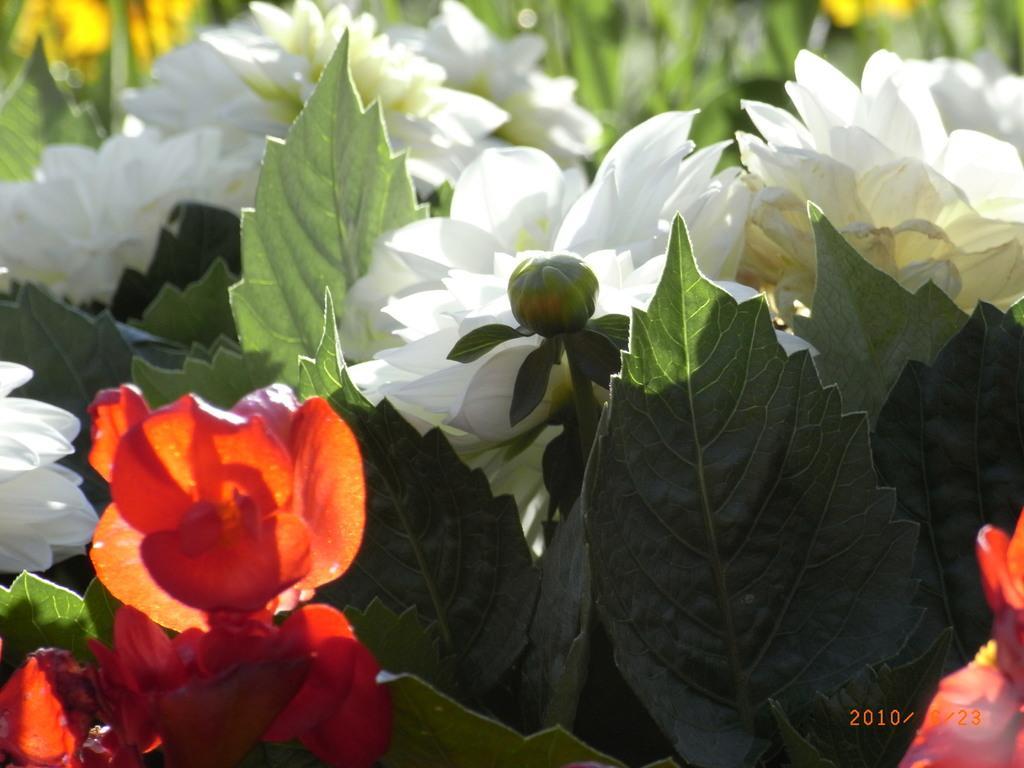How would you summarize this image in a sentence or two? In this picture we can see there are plants with flowers, leaves and a bud. Behind the flowers there is the blurred background. On the image there is a watermark. 